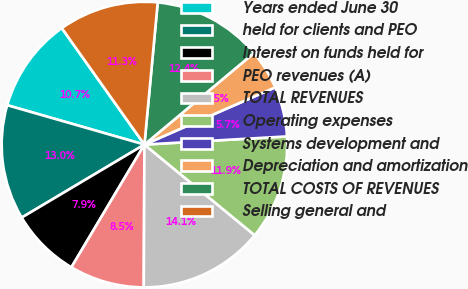<chart> <loc_0><loc_0><loc_500><loc_500><pie_chart><fcel>Years ended June 30<fcel>held for clients and PEO<fcel>Interest on funds held for<fcel>PEO revenues (A)<fcel>TOTAL REVENUES<fcel>Operating expenses<fcel>Systems development and<fcel>Depreciation and amortization<fcel>TOTAL COSTS OF REVENUES<fcel>Selling general and<nl><fcel>10.73%<fcel>12.99%<fcel>7.91%<fcel>8.47%<fcel>14.12%<fcel>11.86%<fcel>5.65%<fcel>4.52%<fcel>12.43%<fcel>11.3%<nl></chart> 